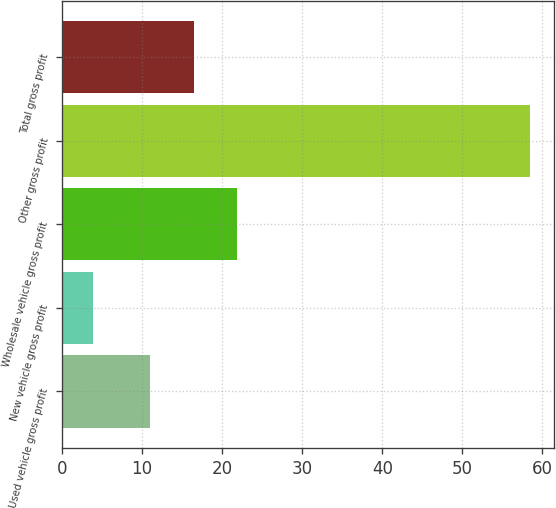Convert chart. <chart><loc_0><loc_0><loc_500><loc_500><bar_chart><fcel>Used vehicle gross profit<fcel>New vehicle gross profit<fcel>Wholesale vehicle gross profit<fcel>Other gross profit<fcel>Total gross profit<nl><fcel>11<fcel>3.9<fcel>21.92<fcel>58.5<fcel>16.46<nl></chart> 